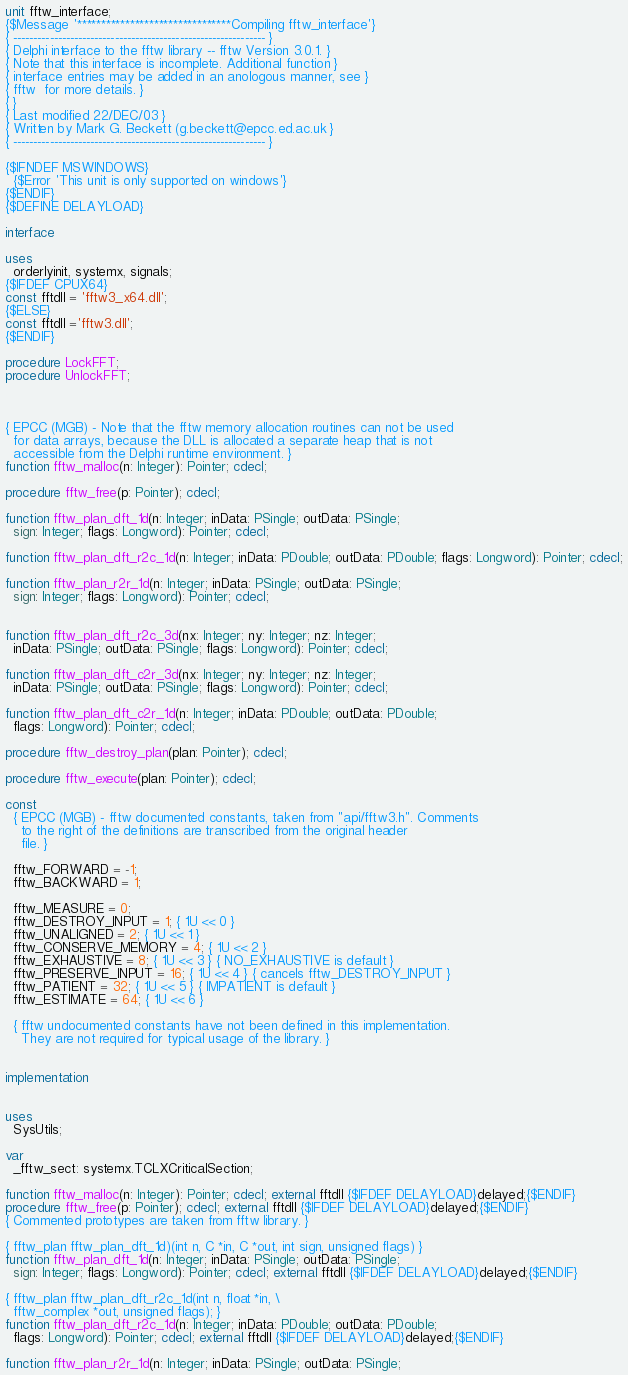Convert code to text. <code><loc_0><loc_0><loc_500><loc_500><_Pascal_>unit fftw_interface;
{$Message '********************************Compiling fftw_interface'}
{ -------------------------------------------------------------- }
{ Delphi interface to the fftw library -- fftw Version 3.0.1. }
{ Note that this interface is incomplete. Additional function }
{ interface entries may be added in an anologous manner, see }
{ fftw  for more details. }
{ }
{ Last modified 22/DEC/03 }
{ Written by Mark G. Beckett (g.beckett@epcc.ed.ac.uk }
{ -------------------------------------------------------------- }

{$IFNDEF MSWINDOWS}
  {$Error 'This unit is only supported on windows'}
{$ENDIF}
{$DEFINE DELAYLOAD}

interface

uses
  orderlyinit, systemx, signals;
{$IFDEF CPUX64}
const fftdll = 'fftw3_x64.dll';
{$ELSE}
const fftdll ='fftw3.dll';
{$ENDIF}

procedure LockFFT;
procedure UnlockFFT;



{ EPCC (MGB) - Note that the fftw memory allocation routines can not be used
  for data arrays, because the DLL is allocated a separate heap that is not
  accessible from the Delphi runtime environment. }
function fftw_malloc(n: Integer): Pointer; cdecl;

procedure fftw_free(p: Pointer); cdecl;

function fftw_plan_dft_1d(n: Integer; inData: PSingle; outData: PSingle;
  sign: Integer; flags: Longword): Pointer; cdecl;

function fftw_plan_dft_r2c_1d(n: Integer; inData: PDouble; outData: PDouble; flags: Longword): Pointer; cdecl;

function fftw_plan_r2r_1d(n: Integer; inData: PSingle; outData: PSingle;
  sign: Integer; flags: Longword): Pointer; cdecl;


function fftw_plan_dft_r2c_3d(nx: Integer; ny: Integer; nz: Integer;
  inData: PSingle; outData: PSingle; flags: Longword): Pointer; cdecl;

function fftw_plan_dft_c2r_3d(nx: Integer; ny: Integer; nz: Integer;
  inData: PSingle; outData: PSingle; flags: Longword): Pointer; cdecl;

function fftw_plan_dft_c2r_1d(n: Integer; inData: PDouble; outData: PDouble;
  flags: Longword): Pointer; cdecl;

procedure fftw_destroy_plan(plan: Pointer); cdecl;

procedure fftw_execute(plan: Pointer); cdecl;

const
  { EPCC (MGB) - fftw documented constants, taken from "api/fftw3.h". Comments
    to the right of the definitions are transcribed from the original header
    file. }

  fftw_FORWARD = -1;
  fftw_BACKWARD = 1;

  fftw_MEASURE = 0;
  fftw_DESTROY_INPUT = 1; { 1U << 0 }
  fftw_UNALIGNED = 2; { 1U << 1 }
  fftw_CONSERVE_MEMORY = 4; { 1U << 2 }
  fftw_EXHAUSTIVE = 8; { 1U << 3 } { NO_EXHAUSTIVE is default }
  fftw_PRESERVE_INPUT = 16; { 1U << 4 } { cancels fftw_DESTROY_INPUT }
  fftw_PATIENT = 32; { 1U << 5 } { IMPATIENT is default }
  fftw_ESTIMATE = 64; { 1U << 6 }

  { fftw undocumented constants have not been defined in this implementation.
    They are not required for typical usage of the library. }


implementation


uses
  SysUtils;

var
  _fftw_sect: systemx.TCLXCriticalSection;

function fftw_malloc(n: Integer): Pointer; cdecl; external fftdll {$IFDEF DELAYLOAD}delayed;{$ENDIF}
procedure fftw_free(p: Pointer); cdecl; external fftdll {$IFDEF DELAYLOAD}delayed;{$ENDIF}
{ Commented prototypes are taken from fftw library. }

{ fftw_plan fftw_plan_dft_1d)(int n, C *in, C *out, int sign, unsigned flags) }
function fftw_plan_dft_1d(n: Integer; inData: PSingle; outData: PSingle;
  sign: Integer; flags: Longword): Pointer; cdecl; external fftdll {$IFDEF DELAYLOAD}delayed;{$ENDIF}

{ fftw_plan fftw_plan_dft_r2c_1d(int n, float *in, \
  fftw_complex *out, unsigned flags); }
function fftw_plan_dft_r2c_1d(n: Integer; inData: PDouble; outData: PDouble;
  flags: Longword): Pointer; cdecl; external fftdll {$IFDEF DELAYLOAD}delayed;{$ENDIF}

function fftw_plan_r2r_1d(n: Integer; inData: PSingle; outData: PSingle;</code> 